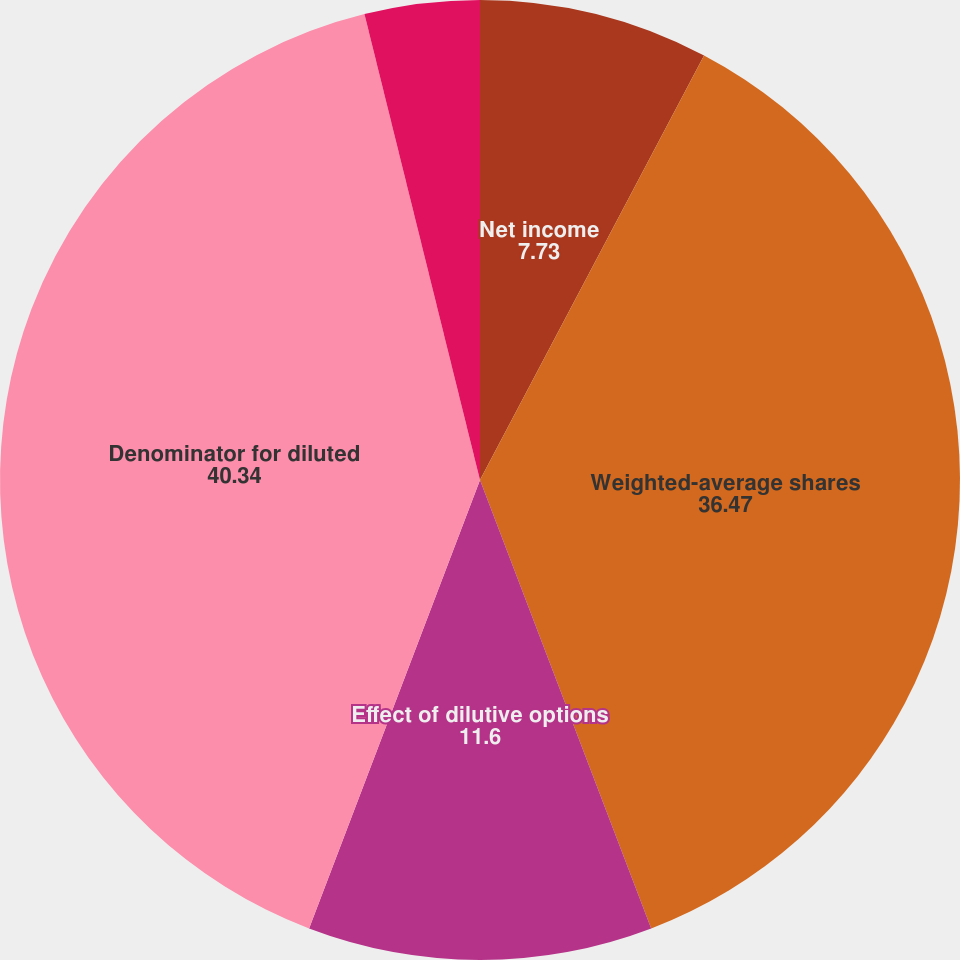<chart> <loc_0><loc_0><loc_500><loc_500><pie_chart><fcel>Net income<fcel>Weighted-average shares<fcel>Effect of dilutive options<fcel>Denominator for diluted<fcel>Basic earnings per share<fcel>Diluted earnings per share<nl><fcel>7.73%<fcel>36.47%<fcel>11.6%<fcel>40.34%<fcel>3.87%<fcel>0.0%<nl></chart> 